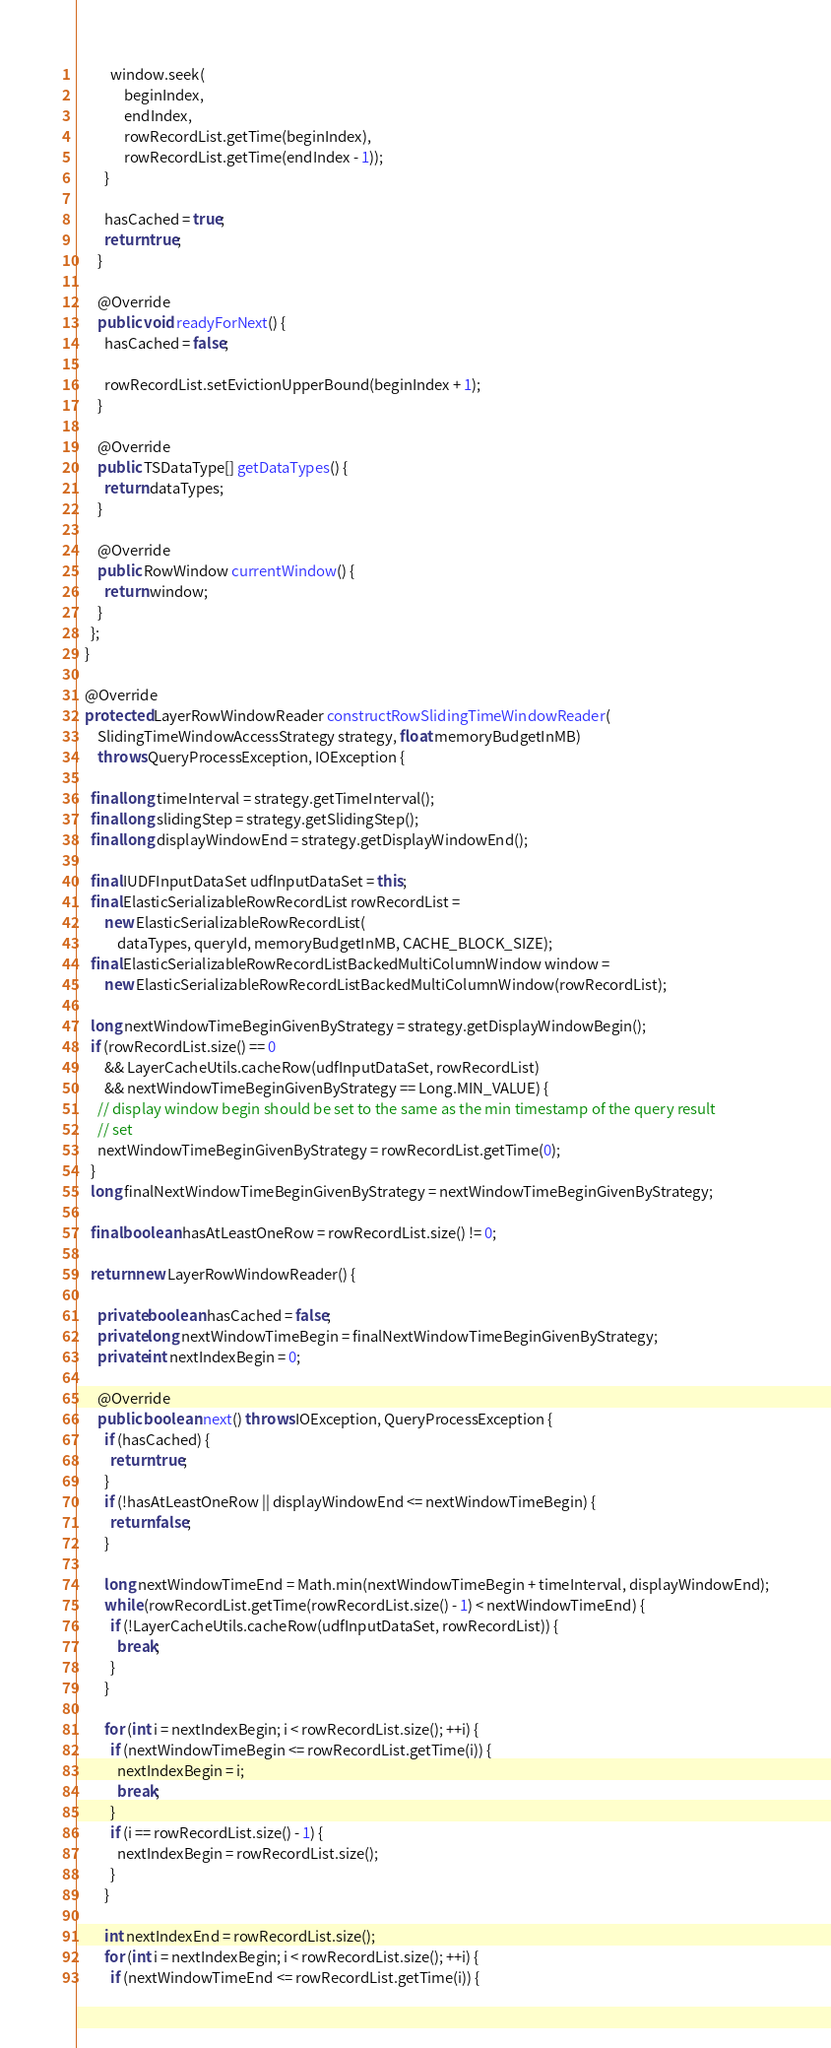<code> <loc_0><loc_0><loc_500><loc_500><_Java_>          window.seek(
              beginIndex,
              endIndex,
              rowRecordList.getTime(beginIndex),
              rowRecordList.getTime(endIndex - 1));
        }

        hasCached = true;
        return true;
      }

      @Override
      public void readyForNext() {
        hasCached = false;

        rowRecordList.setEvictionUpperBound(beginIndex + 1);
      }

      @Override
      public TSDataType[] getDataTypes() {
        return dataTypes;
      }

      @Override
      public RowWindow currentWindow() {
        return window;
      }
    };
  }

  @Override
  protected LayerRowWindowReader constructRowSlidingTimeWindowReader(
      SlidingTimeWindowAccessStrategy strategy, float memoryBudgetInMB)
      throws QueryProcessException, IOException {

    final long timeInterval = strategy.getTimeInterval();
    final long slidingStep = strategy.getSlidingStep();
    final long displayWindowEnd = strategy.getDisplayWindowEnd();

    final IUDFInputDataSet udfInputDataSet = this;
    final ElasticSerializableRowRecordList rowRecordList =
        new ElasticSerializableRowRecordList(
            dataTypes, queryId, memoryBudgetInMB, CACHE_BLOCK_SIZE);
    final ElasticSerializableRowRecordListBackedMultiColumnWindow window =
        new ElasticSerializableRowRecordListBackedMultiColumnWindow(rowRecordList);

    long nextWindowTimeBeginGivenByStrategy = strategy.getDisplayWindowBegin();
    if (rowRecordList.size() == 0
        && LayerCacheUtils.cacheRow(udfInputDataSet, rowRecordList)
        && nextWindowTimeBeginGivenByStrategy == Long.MIN_VALUE) {
      // display window begin should be set to the same as the min timestamp of the query result
      // set
      nextWindowTimeBeginGivenByStrategy = rowRecordList.getTime(0);
    }
    long finalNextWindowTimeBeginGivenByStrategy = nextWindowTimeBeginGivenByStrategy;

    final boolean hasAtLeastOneRow = rowRecordList.size() != 0;

    return new LayerRowWindowReader() {

      private boolean hasCached = false;
      private long nextWindowTimeBegin = finalNextWindowTimeBeginGivenByStrategy;
      private int nextIndexBegin = 0;

      @Override
      public boolean next() throws IOException, QueryProcessException {
        if (hasCached) {
          return true;
        }
        if (!hasAtLeastOneRow || displayWindowEnd <= nextWindowTimeBegin) {
          return false;
        }

        long nextWindowTimeEnd = Math.min(nextWindowTimeBegin + timeInterval, displayWindowEnd);
        while (rowRecordList.getTime(rowRecordList.size() - 1) < nextWindowTimeEnd) {
          if (!LayerCacheUtils.cacheRow(udfInputDataSet, rowRecordList)) {
            break;
          }
        }

        for (int i = nextIndexBegin; i < rowRecordList.size(); ++i) {
          if (nextWindowTimeBegin <= rowRecordList.getTime(i)) {
            nextIndexBegin = i;
            break;
          }
          if (i == rowRecordList.size() - 1) {
            nextIndexBegin = rowRecordList.size();
          }
        }

        int nextIndexEnd = rowRecordList.size();
        for (int i = nextIndexBegin; i < rowRecordList.size(); ++i) {
          if (nextWindowTimeEnd <= rowRecordList.getTime(i)) {</code> 